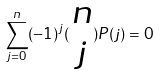<formula> <loc_0><loc_0><loc_500><loc_500>\sum _ { j = 0 } ^ { n } ( - 1 ) ^ { j } ( \begin{matrix} n \\ j \end{matrix} ) P ( j ) = 0</formula> 